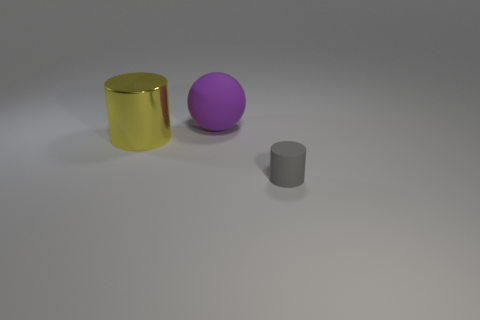Are there any other things that are the same size as the gray matte cylinder?
Keep it short and to the point. No. Are there any other things that have the same shape as the big purple thing?
Your answer should be very brief. No. Is there anything else that has the same material as the yellow thing?
Make the answer very short. No. The purple matte thing that is the same size as the yellow metal thing is what shape?
Your answer should be compact. Sphere. Are there any big yellow objects that have the same shape as the tiny object?
Offer a terse response. Yes. Is the material of the large yellow cylinder the same as the thing that is on the right side of the large purple ball?
Your response must be concise. No. What number of other things are the same material as the tiny gray thing?
Keep it short and to the point. 1. Are there more yellow metal cylinders that are in front of the big purple object than tiny blue matte cylinders?
Provide a short and direct response. Yes. What number of cylinders are on the right side of the large object behind the cylinder that is left of the sphere?
Your response must be concise. 1. There is a object on the right side of the matte ball; does it have the same shape as the yellow shiny thing?
Offer a terse response. Yes. 